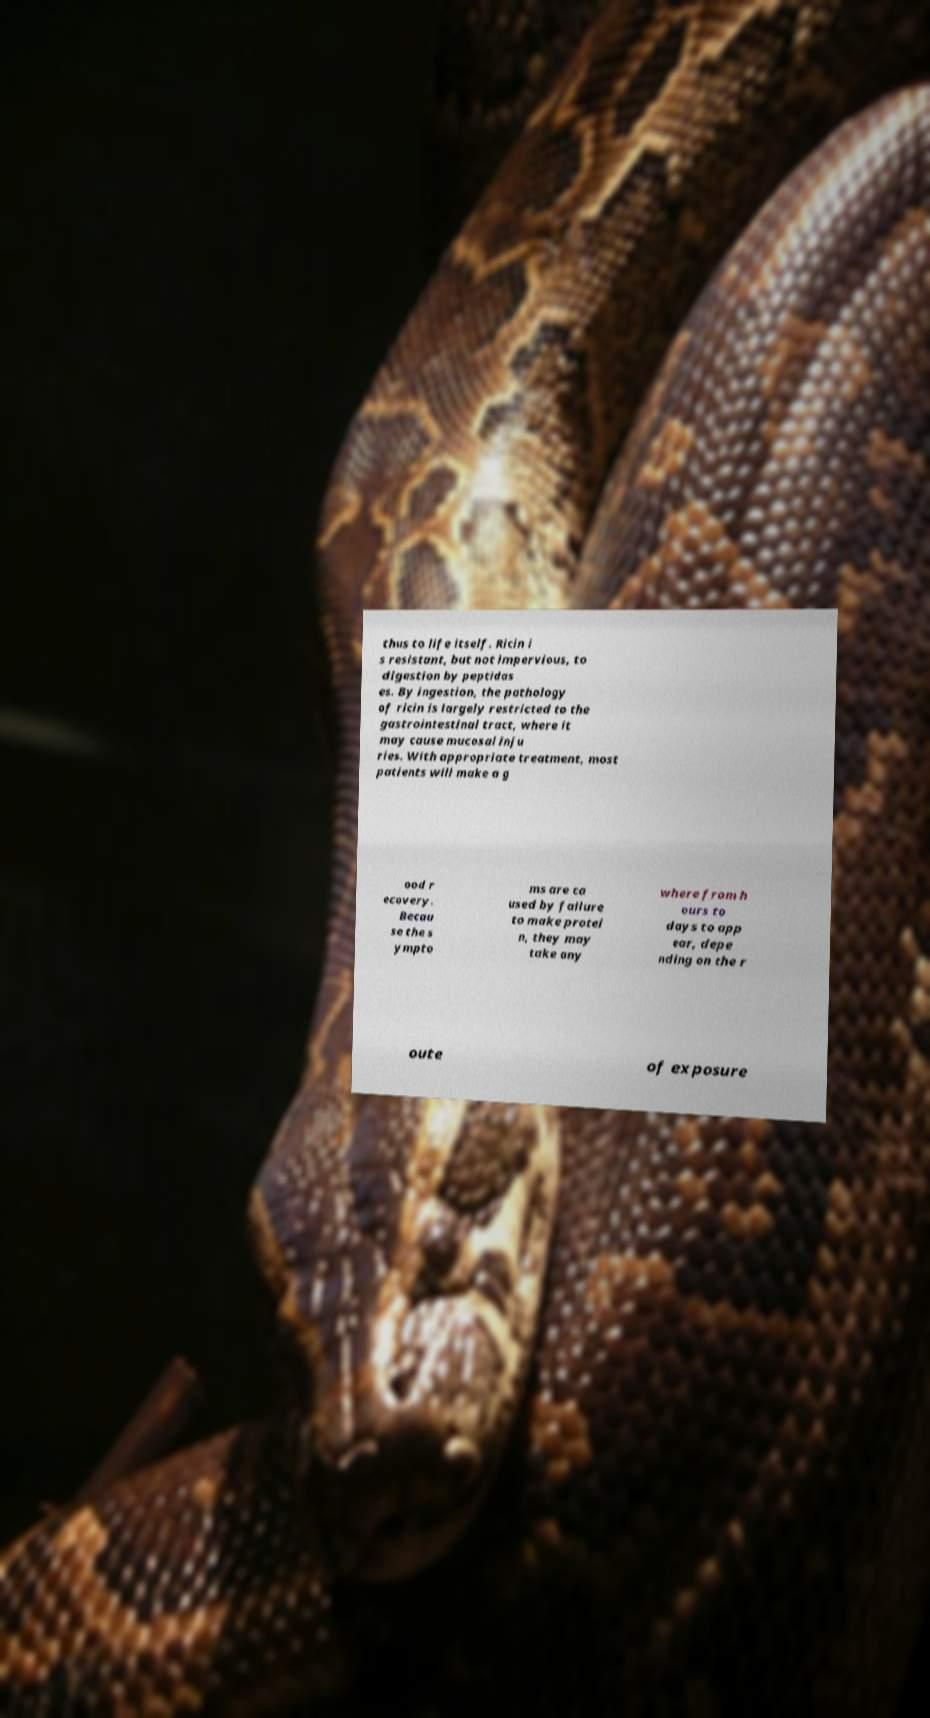There's text embedded in this image that I need extracted. Can you transcribe it verbatim? thus to life itself. Ricin i s resistant, but not impervious, to digestion by peptidas es. By ingestion, the pathology of ricin is largely restricted to the gastrointestinal tract, where it may cause mucosal inju ries. With appropriate treatment, most patients will make a g ood r ecovery. Becau se the s ympto ms are ca used by failure to make protei n, they may take any where from h ours to days to app ear, depe nding on the r oute of exposure 